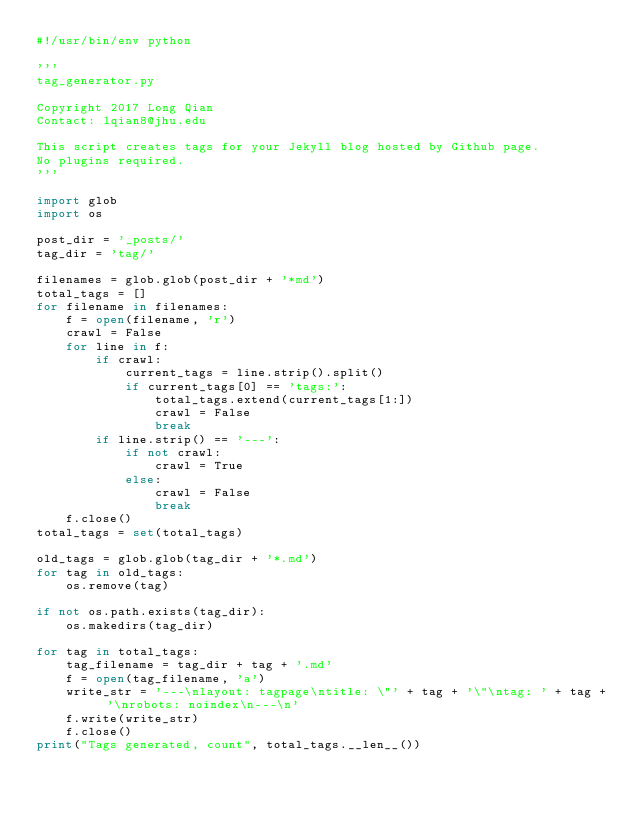<code> <loc_0><loc_0><loc_500><loc_500><_Python_>#!/usr/bin/env python

'''
tag_generator.py

Copyright 2017 Long Qian
Contact: lqian8@jhu.edu

This script creates tags for your Jekyll blog hosted by Github page.
No plugins required.
'''

import glob
import os

post_dir = '_posts/'
tag_dir = 'tag/'

filenames = glob.glob(post_dir + '*md')
total_tags = []
for filename in filenames:
    f = open(filename, 'r')
    crawl = False
    for line in f:
        if crawl:
            current_tags = line.strip().split()
            if current_tags[0] == 'tags:':
                total_tags.extend(current_tags[1:])
                crawl = False
                break
        if line.strip() == '---':
            if not crawl:
                crawl = True
            else:
                crawl = False
                break
    f.close()
total_tags = set(total_tags)

old_tags = glob.glob(tag_dir + '*.md')
for tag in old_tags:
    os.remove(tag)

if not os.path.exists(tag_dir):
    os.makedirs(tag_dir)

for tag in total_tags:
    tag_filename = tag_dir + tag + '.md'
    f = open(tag_filename, 'a')
    write_str = '---\nlayout: tagpage\ntitle: \"' + tag + '\"\ntag: ' + tag + '\nrobots: noindex\n---\n'
    f.write(write_str)
    f.close()
print("Tags generated, count", total_tags.__len__())
</code> 